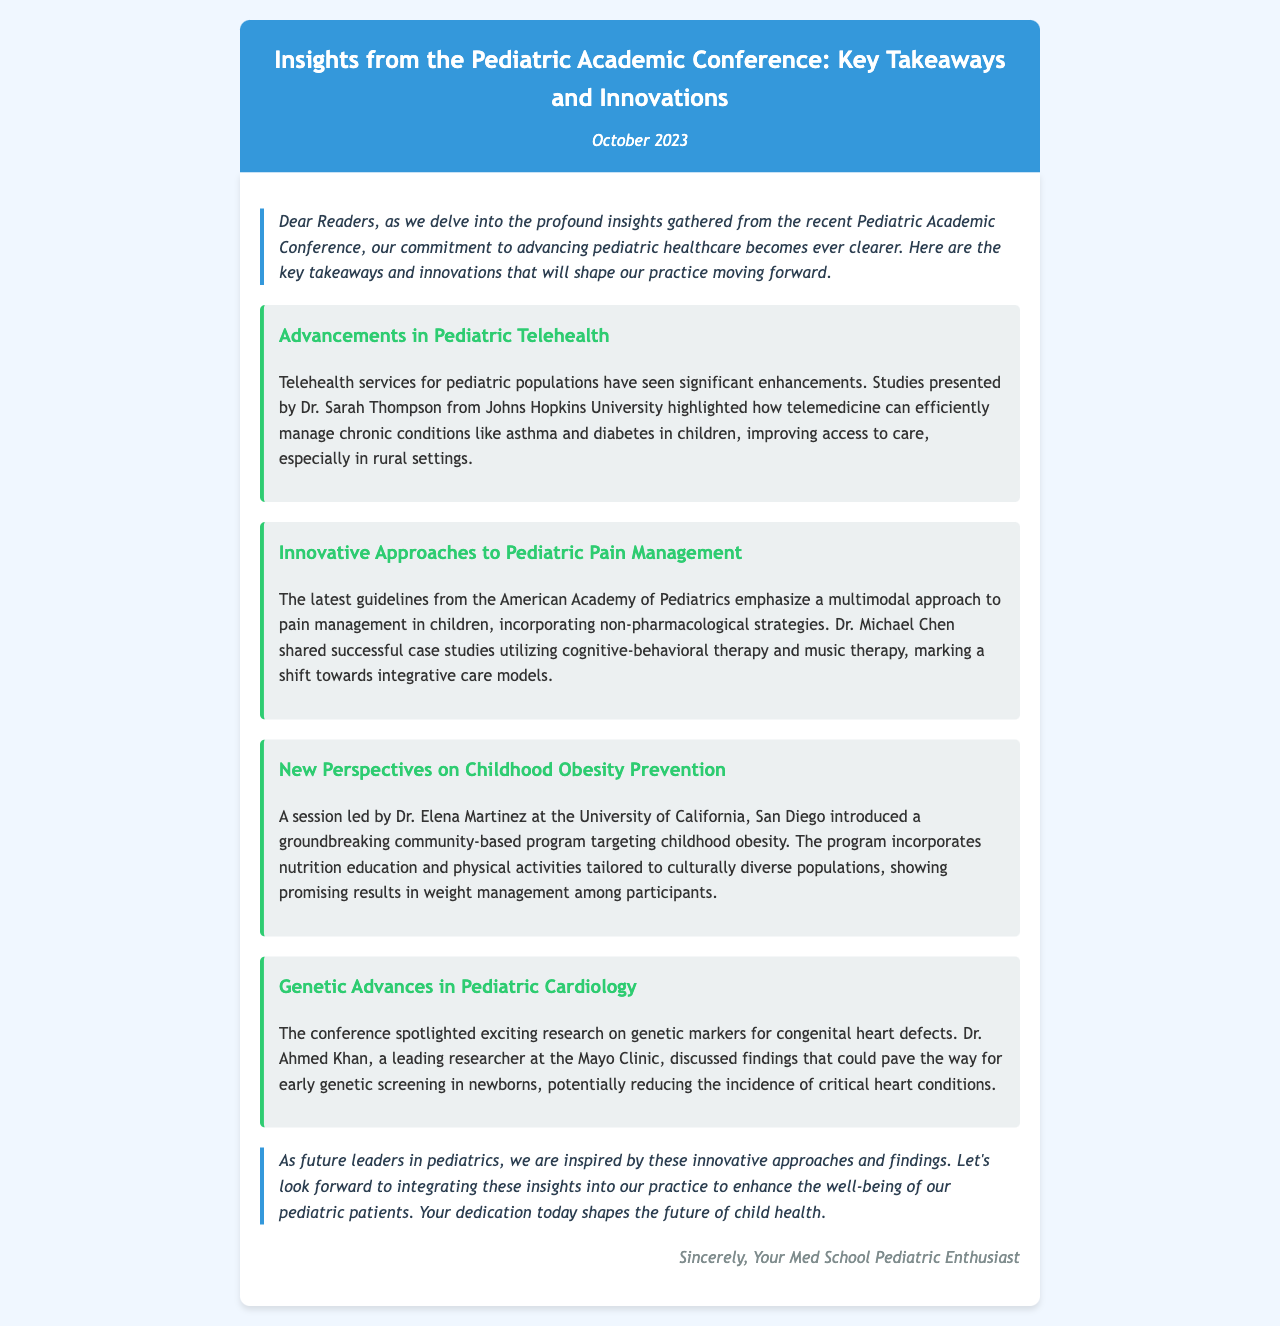What is the title of the newsletter? The title of the newsletter is displayed prominently at the top of the document, which is "Insights from the Pediatric Academic Conference: Key Takeaways and Innovations".
Answer: Insights from the Pediatric Academic Conference: Key Takeaways and Innovations Who presented the advancements in pediatric telehealth? The document includes the name of the presenter associated with advancements in pediatric telehealth, which is Dr. Sarah Thompson.
Answer: Dr. Sarah Thompson What innovative approach to pain management was emphasized? The document highlights a specific approach to pain management in children that incorporates non-pharmacological strategies.
Answer: Multimodal approach What is the focus of the session led by Dr. Elena Martinez? The document describes a session led by Dr. Elena Martinez focusing on a particular community-based program related to childhood obesity.
Answer: Childhood obesity prevention Which organization provided the latest guidelines on pediatric pain management? The document states that the guidelines come from a specific prestigious organization, which is the American Academy of Pediatrics.
Answer: American Academy of Pediatrics What month was the Pediatric Academic Conference held? The date of the newsletter reflects the month in which the conference occurred, indicated as October.
Answer: October What area does Dr. Ahmed Khan specialize in? The document specifies the field of research associated with Dr. Ahmed Khan, which is pediatric cardiology.
Answer: Pediatric cardiology Which therapy was mentioned as part of the pain management strategies? The document describes specific therapies utilized in pain management, one of which is music therapy.
Answer: Music therapy 